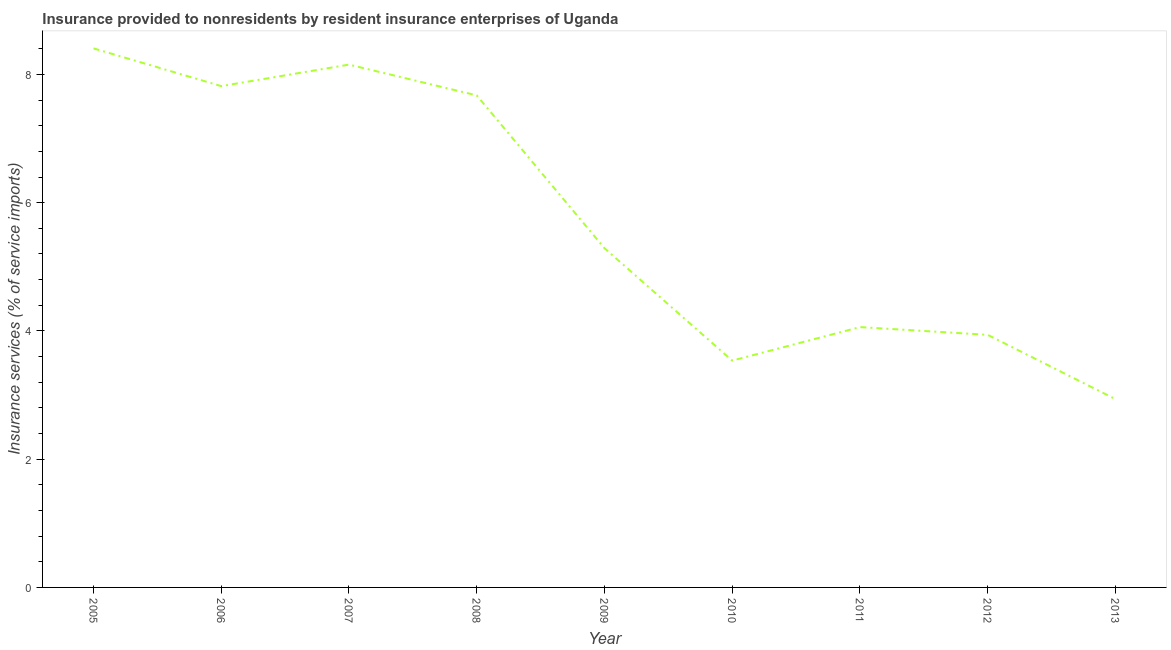What is the insurance and financial services in 2007?
Make the answer very short. 8.15. Across all years, what is the maximum insurance and financial services?
Your response must be concise. 8.41. Across all years, what is the minimum insurance and financial services?
Keep it short and to the point. 2.94. What is the sum of the insurance and financial services?
Keep it short and to the point. 51.82. What is the difference between the insurance and financial services in 2009 and 2013?
Give a very brief answer. 2.35. What is the average insurance and financial services per year?
Your answer should be compact. 5.76. What is the median insurance and financial services?
Your response must be concise. 5.29. In how many years, is the insurance and financial services greater than 6 %?
Ensure brevity in your answer.  4. Do a majority of the years between 2013 and 2006 (inclusive) have insurance and financial services greater than 6 %?
Provide a short and direct response. Yes. What is the ratio of the insurance and financial services in 2006 to that in 2007?
Ensure brevity in your answer.  0.96. Is the difference between the insurance and financial services in 2007 and 2010 greater than the difference between any two years?
Provide a short and direct response. No. What is the difference between the highest and the second highest insurance and financial services?
Your answer should be compact. 0.25. What is the difference between the highest and the lowest insurance and financial services?
Your answer should be compact. 5.47. In how many years, is the insurance and financial services greater than the average insurance and financial services taken over all years?
Offer a terse response. 4. Does the insurance and financial services monotonically increase over the years?
Offer a terse response. No. How many lines are there?
Give a very brief answer. 1. Does the graph contain any zero values?
Your response must be concise. No. Does the graph contain grids?
Make the answer very short. No. What is the title of the graph?
Offer a very short reply. Insurance provided to nonresidents by resident insurance enterprises of Uganda. What is the label or title of the X-axis?
Keep it short and to the point. Year. What is the label or title of the Y-axis?
Make the answer very short. Insurance services (% of service imports). What is the Insurance services (% of service imports) in 2005?
Your answer should be very brief. 8.41. What is the Insurance services (% of service imports) of 2006?
Ensure brevity in your answer.  7.82. What is the Insurance services (% of service imports) in 2007?
Provide a succinct answer. 8.15. What is the Insurance services (% of service imports) in 2008?
Your answer should be compact. 7.67. What is the Insurance services (% of service imports) of 2009?
Your answer should be very brief. 5.29. What is the Insurance services (% of service imports) in 2010?
Offer a terse response. 3.54. What is the Insurance services (% of service imports) in 2011?
Offer a very short reply. 4.06. What is the Insurance services (% of service imports) in 2012?
Offer a terse response. 3.94. What is the Insurance services (% of service imports) in 2013?
Provide a succinct answer. 2.94. What is the difference between the Insurance services (% of service imports) in 2005 and 2006?
Keep it short and to the point. 0.59. What is the difference between the Insurance services (% of service imports) in 2005 and 2007?
Your response must be concise. 0.25. What is the difference between the Insurance services (% of service imports) in 2005 and 2008?
Give a very brief answer. 0.73. What is the difference between the Insurance services (% of service imports) in 2005 and 2009?
Your response must be concise. 3.12. What is the difference between the Insurance services (% of service imports) in 2005 and 2010?
Provide a succinct answer. 4.87. What is the difference between the Insurance services (% of service imports) in 2005 and 2011?
Give a very brief answer. 4.35. What is the difference between the Insurance services (% of service imports) in 2005 and 2012?
Offer a terse response. 4.47. What is the difference between the Insurance services (% of service imports) in 2005 and 2013?
Keep it short and to the point. 5.47. What is the difference between the Insurance services (% of service imports) in 2006 and 2007?
Give a very brief answer. -0.34. What is the difference between the Insurance services (% of service imports) in 2006 and 2008?
Provide a short and direct response. 0.14. What is the difference between the Insurance services (% of service imports) in 2006 and 2009?
Offer a very short reply. 2.53. What is the difference between the Insurance services (% of service imports) in 2006 and 2010?
Ensure brevity in your answer.  4.28. What is the difference between the Insurance services (% of service imports) in 2006 and 2011?
Provide a succinct answer. 3.76. What is the difference between the Insurance services (% of service imports) in 2006 and 2012?
Your response must be concise. 3.88. What is the difference between the Insurance services (% of service imports) in 2006 and 2013?
Your answer should be compact. 4.88. What is the difference between the Insurance services (% of service imports) in 2007 and 2008?
Your response must be concise. 0.48. What is the difference between the Insurance services (% of service imports) in 2007 and 2009?
Offer a very short reply. 2.86. What is the difference between the Insurance services (% of service imports) in 2007 and 2010?
Make the answer very short. 4.62. What is the difference between the Insurance services (% of service imports) in 2007 and 2011?
Ensure brevity in your answer.  4.09. What is the difference between the Insurance services (% of service imports) in 2007 and 2012?
Your answer should be very brief. 4.21. What is the difference between the Insurance services (% of service imports) in 2007 and 2013?
Provide a short and direct response. 5.22. What is the difference between the Insurance services (% of service imports) in 2008 and 2009?
Provide a succinct answer. 2.38. What is the difference between the Insurance services (% of service imports) in 2008 and 2010?
Offer a terse response. 4.14. What is the difference between the Insurance services (% of service imports) in 2008 and 2011?
Provide a succinct answer. 3.61. What is the difference between the Insurance services (% of service imports) in 2008 and 2012?
Provide a short and direct response. 3.73. What is the difference between the Insurance services (% of service imports) in 2008 and 2013?
Give a very brief answer. 4.74. What is the difference between the Insurance services (% of service imports) in 2009 and 2010?
Your response must be concise. 1.75. What is the difference between the Insurance services (% of service imports) in 2009 and 2011?
Your response must be concise. 1.23. What is the difference between the Insurance services (% of service imports) in 2009 and 2012?
Provide a succinct answer. 1.35. What is the difference between the Insurance services (% of service imports) in 2009 and 2013?
Keep it short and to the point. 2.35. What is the difference between the Insurance services (% of service imports) in 2010 and 2011?
Provide a succinct answer. -0.52. What is the difference between the Insurance services (% of service imports) in 2010 and 2012?
Your response must be concise. -0.4. What is the difference between the Insurance services (% of service imports) in 2010 and 2013?
Offer a terse response. 0.6. What is the difference between the Insurance services (% of service imports) in 2011 and 2012?
Provide a short and direct response. 0.12. What is the difference between the Insurance services (% of service imports) in 2011 and 2013?
Ensure brevity in your answer.  1.12. What is the difference between the Insurance services (% of service imports) in 2012 and 2013?
Keep it short and to the point. 1. What is the ratio of the Insurance services (% of service imports) in 2005 to that in 2006?
Make the answer very short. 1.07. What is the ratio of the Insurance services (% of service imports) in 2005 to that in 2007?
Your answer should be very brief. 1.03. What is the ratio of the Insurance services (% of service imports) in 2005 to that in 2008?
Give a very brief answer. 1.1. What is the ratio of the Insurance services (% of service imports) in 2005 to that in 2009?
Ensure brevity in your answer.  1.59. What is the ratio of the Insurance services (% of service imports) in 2005 to that in 2010?
Keep it short and to the point. 2.38. What is the ratio of the Insurance services (% of service imports) in 2005 to that in 2011?
Offer a very short reply. 2.07. What is the ratio of the Insurance services (% of service imports) in 2005 to that in 2012?
Offer a terse response. 2.13. What is the ratio of the Insurance services (% of service imports) in 2005 to that in 2013?
Provide a short and direct response. 2.86. What is the ratio of the Insurance services (% of service imports) in 2006 to that in 2007?
Your response must be concise. 0.96. What is the ratio of the Insurance services (% of service imports) in 2006 to that in 2008?
Offer a very short reply. 1.02. What is the ratio of the Insurance services (% of service imports) in 2006 to that in 2009?
Provide a short and direct response. 1.48. What is the ratio of the Insurance services (% of service imports) in 2006 to that in 2010?
Offer a very short reply. 2.21. What is the ratio of the Insurance services (% of service imports) in 2006 to that in 2011?
Your response must be concise. 1.93. What is the ratio of the Insurance services (% of service imports) in 2006 to that in 2012?
Your answer should be compact. 1.99. What is the ratio of the Insurance services (% of service imports) in 2006 to that in 2013?
Keep it short and to the point. 2.66. What is the ratio of the Insurance services (% of service imports) in 2007 to that in 2008?
Provide a short and direct response. 1.06. What is the ratio of the Insurance services (% of service imports) in 2007 to that in 2009?
Offer a terse response. 1.54. What is the ratio of the Insurance services (% of service imports) in 2007 to that in 2010?
Make the answer very short. 2.31. What is the ratio of the Insurance services (% of service imports) in 2007 to that in 2011?
Give a very brief answer. 2.01. What is the ratio of the Insurance services (% of service imports) in 2007 to that in 2012?
Offer a very short reply. 2.07. What is the ratio of the Insurance services (% of service imports) in 2007 to that in 2013?
Offer a very short reply. 2.78. What is the ratio of the Insurance services (% of service imports) in 2008 to that in 2009?
Provide a succinct answer. 1.45. What is the ratio of the Insurance services (% of service imports) in 2008 to that in 2010?
Offer a very short reply. 2.17. What is the ratio of the Insurance services (% of service imports) in 2008 to that in 2011?
Provide a succinct answer. 1.89. What is the ratio of the Insurance services (% of service imports) in 2008 to that in 2012?
Your response must be concise. 1.95. What is the ratio of the Insurance services (% of service imports) in 2008 to that in 2013?
Your answer should be compact. 2.61. What is the ratio of the Insurance services (% of service imports) in 2009 to that in 2010?
Keep it short and to the point. 1.5. What is the ratio of the Insurance services (% of service imports) in 2009 to that in 2011?
Your answer should be very brief. 1.3. What is the ratio of the Insurance services (% of service imports) in 2009 to that in 2012?
Give a very brief answer. 1.34. What is the ratio of the Insurance services (% of service imports) in 2009 to that in 2013?
Provide a short and direct response. 1.8. What is the ratio of the Insurance services (% of service imports) in 2010 to that in 2011?
Offer a very short reply. 0.87. What is the ratio of the Insurance services (% of service imports) in 2010 to that in 2012?
Your answer should be very brief. 0.9. What is the ratio of the Insurance services (% of service imports) in 2010 to that in 2013?
Offer a terse response. 1.2. What is the ratio of the Insurance services (% of service imports) in 2011 to that in 2012?
Offer a very short reply. 1.03. What is the ratio of the Insurance services (% of service imports) in 2011 to that in 2013?
Provide a succinct answer. 1.38. What is the ratio of the Insurance services (% of service imports) in 2012 to that in 2013?
Offer a terse response. 1.34. 